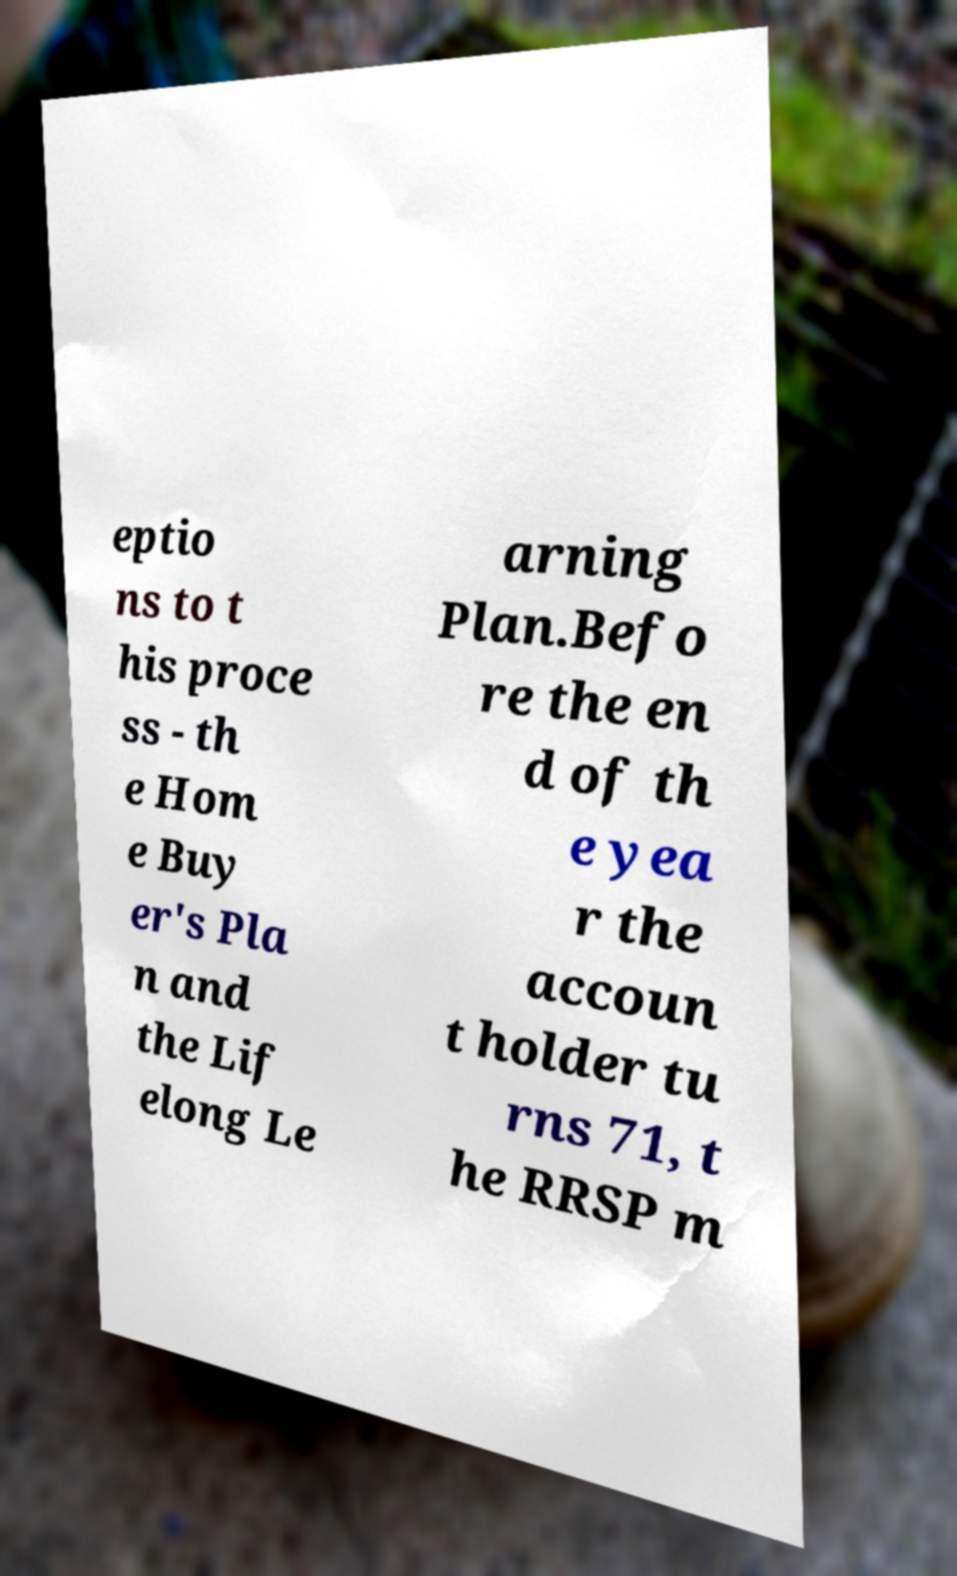Can you read and provide the text displayed in the image?This photo seems to have some interesting text. Can you extract and type it out for me? eptio ns to t his proce ss - th e Hom e Buy er's Pla n and the Lif elong Le arning Plan.Befo re the en d of th e yea r the accoun t holder tu rns 71, t he RRSP m 